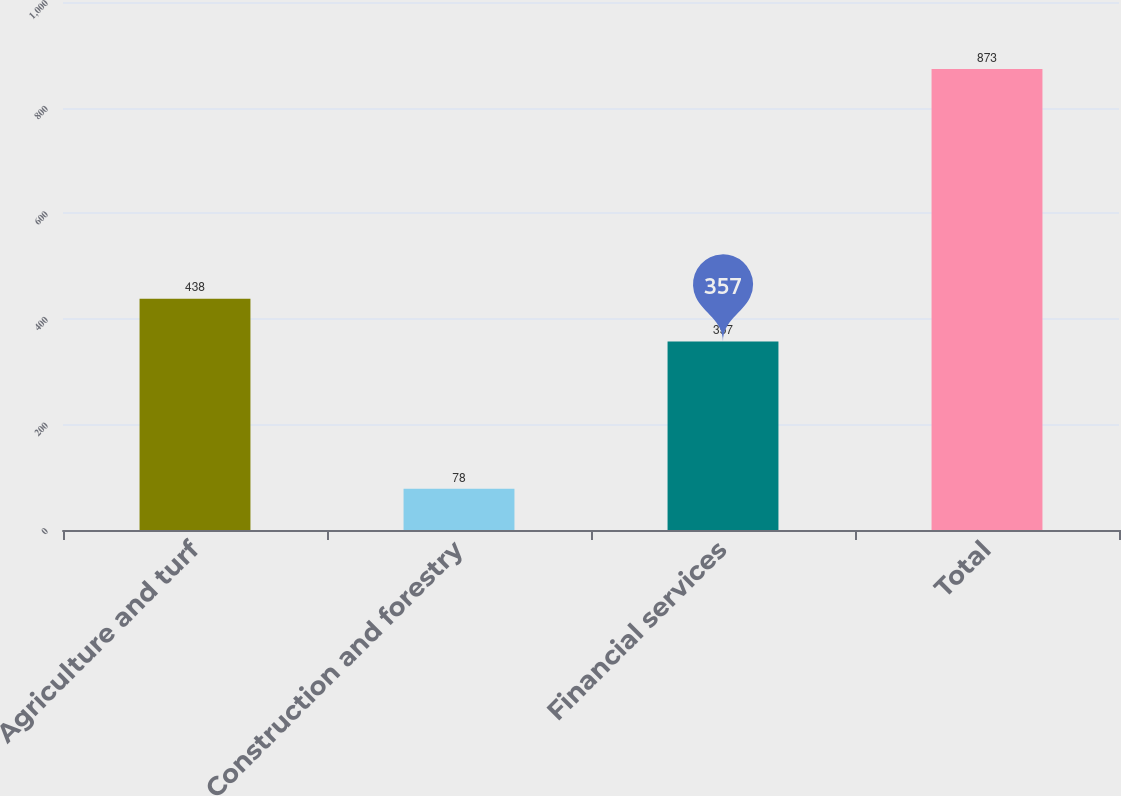Convert chart to OTSL. <chart><loc_0><loc_0><loc_500><loc_500><bar_chart><fcel>Agriculture and turf<fcel>Construction and forestry<fcel>Financial services<fcel>Total<nl><fcel>438<fcel>78<fcel>357<fcel>873<nl></chart> 